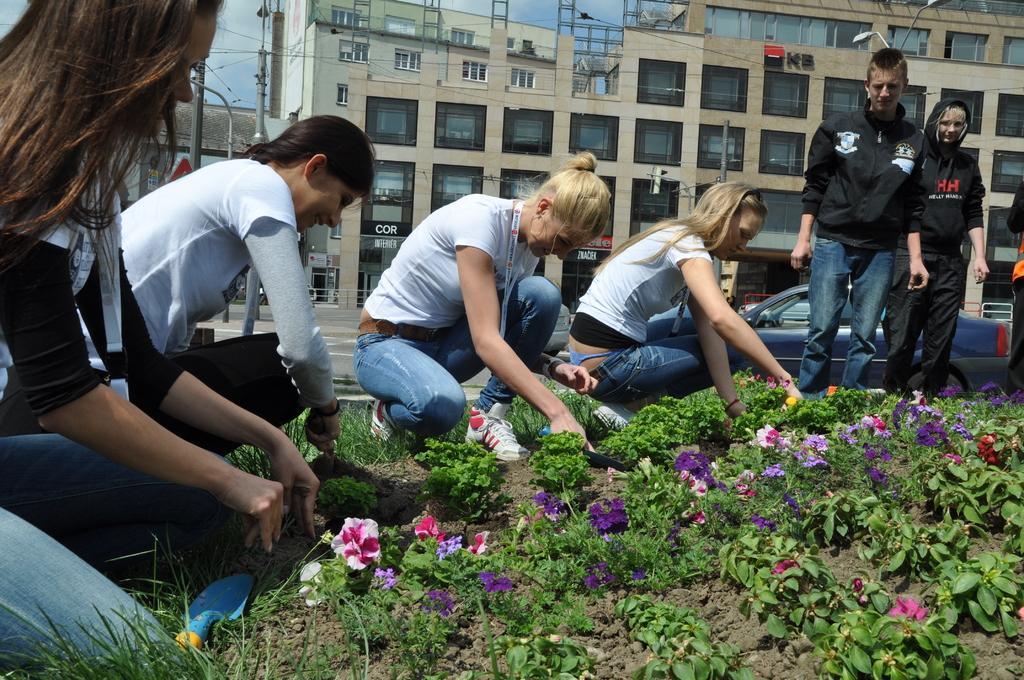In one or two sentences, can you explain what this image depicts? In this image I can see the ground, few plants which are green in color and few flowers which are purple, pink and cream in color. I can see few persons sitting, few persons standing and few vehicles on the road. In the background I can see few poles, few wires, few buildings and the sky. 